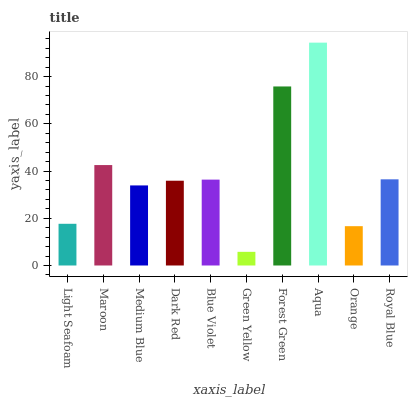Is Green Yellow the minimum?
Answer yes or no. Yes. Is Aqua the maximum?
Answer yes or no. Yes. Is Maroon the minimum?
Answer yes or no. No. Is Maroon the maximum?
Answer yes or no. No. Is Maroon greater than Light Seafoam?
Answer yes or no. Yes. Is Light Seafoam less than Maroon?
Answer yes or no. Yes. Is Light Seafoam greater than Maroon?
Answer yes or no. No. Is Maroon less than Light Seafoam?
Answer yes or no. No. Is Blue Violet the high median?
Answer yes or no. Yes. Is Dark Red the low median?
Answer yes or no. Yes. Is Maroon the high median?
Answer yes or no. No. Is Orange the low median?
Answer yes or no. No. 